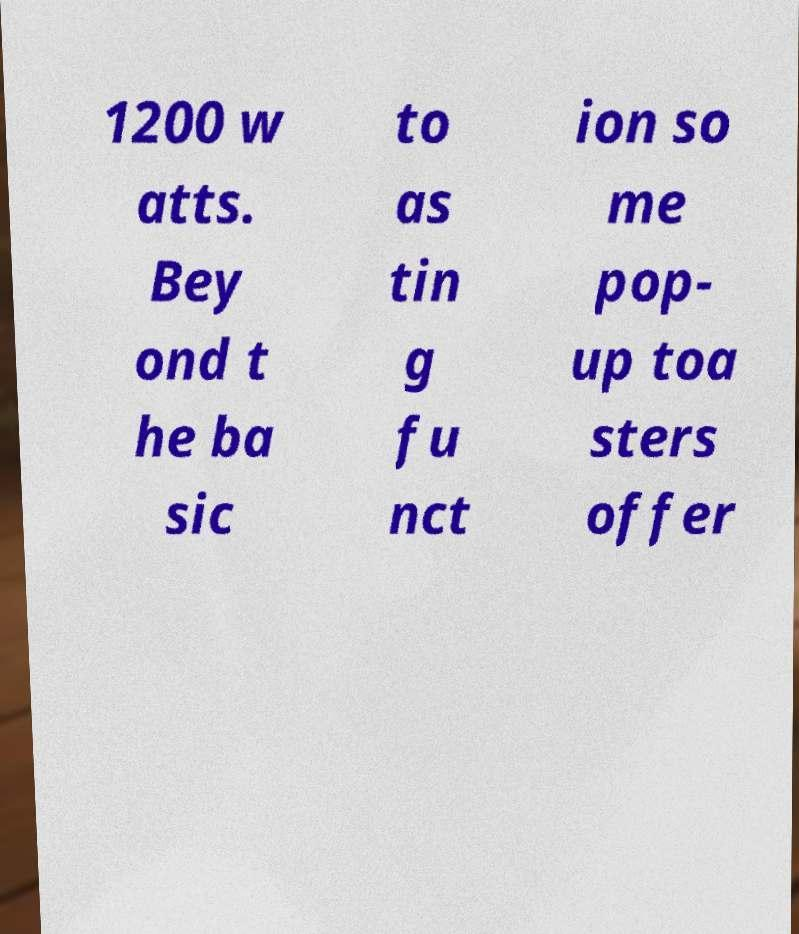For documentation purposes, I need the text within this image transcribed. Could you provide that? 1200 w atts. Bey ond t he ba sic to as tin g fu nct ion so me pop- up toa sters offer 